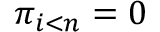Convert formula to latex. <formula><loc_0><loc_0><loc_500><loc_500>\pi _ { i < n } = 0</formula> 